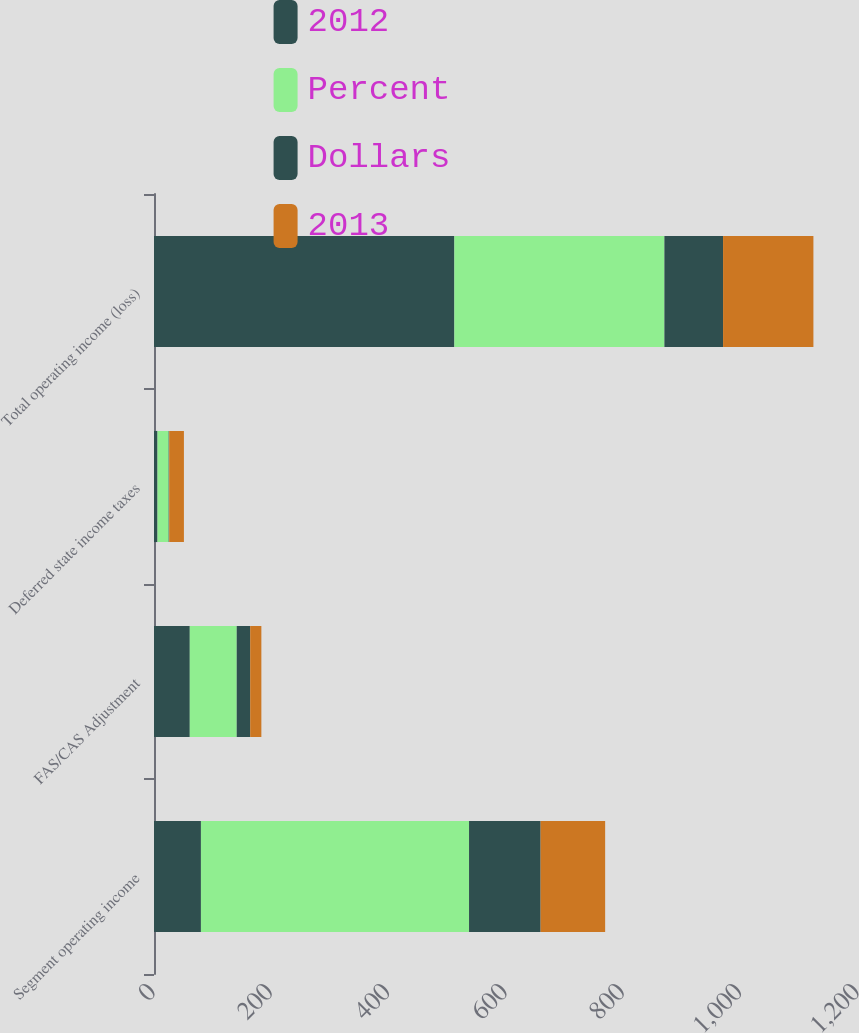Convert chart to OTSL. <chart><loc_0><loc_0><loc_500><loc_500><stacked_bar_chart><ecel><fcel>Segment operating income<fcel>FAS/CAS Adjustment<fcel>Deferred state income taxes<fcel>Total operating income (loss)<nl><fcel>2012<fcel>80<fcel>61<fcel>6<fcel>512<nl><fcel>Percent<fcel>457<fcel>80<fcel>19<fcel>358<nl><fcel>Dollars<fcel>122<fcel>23<fcel>1<fcel>100<nl><fcel>2013<fcel>110<fcel>19<fcel>25<fcel>154<nl></chart> 